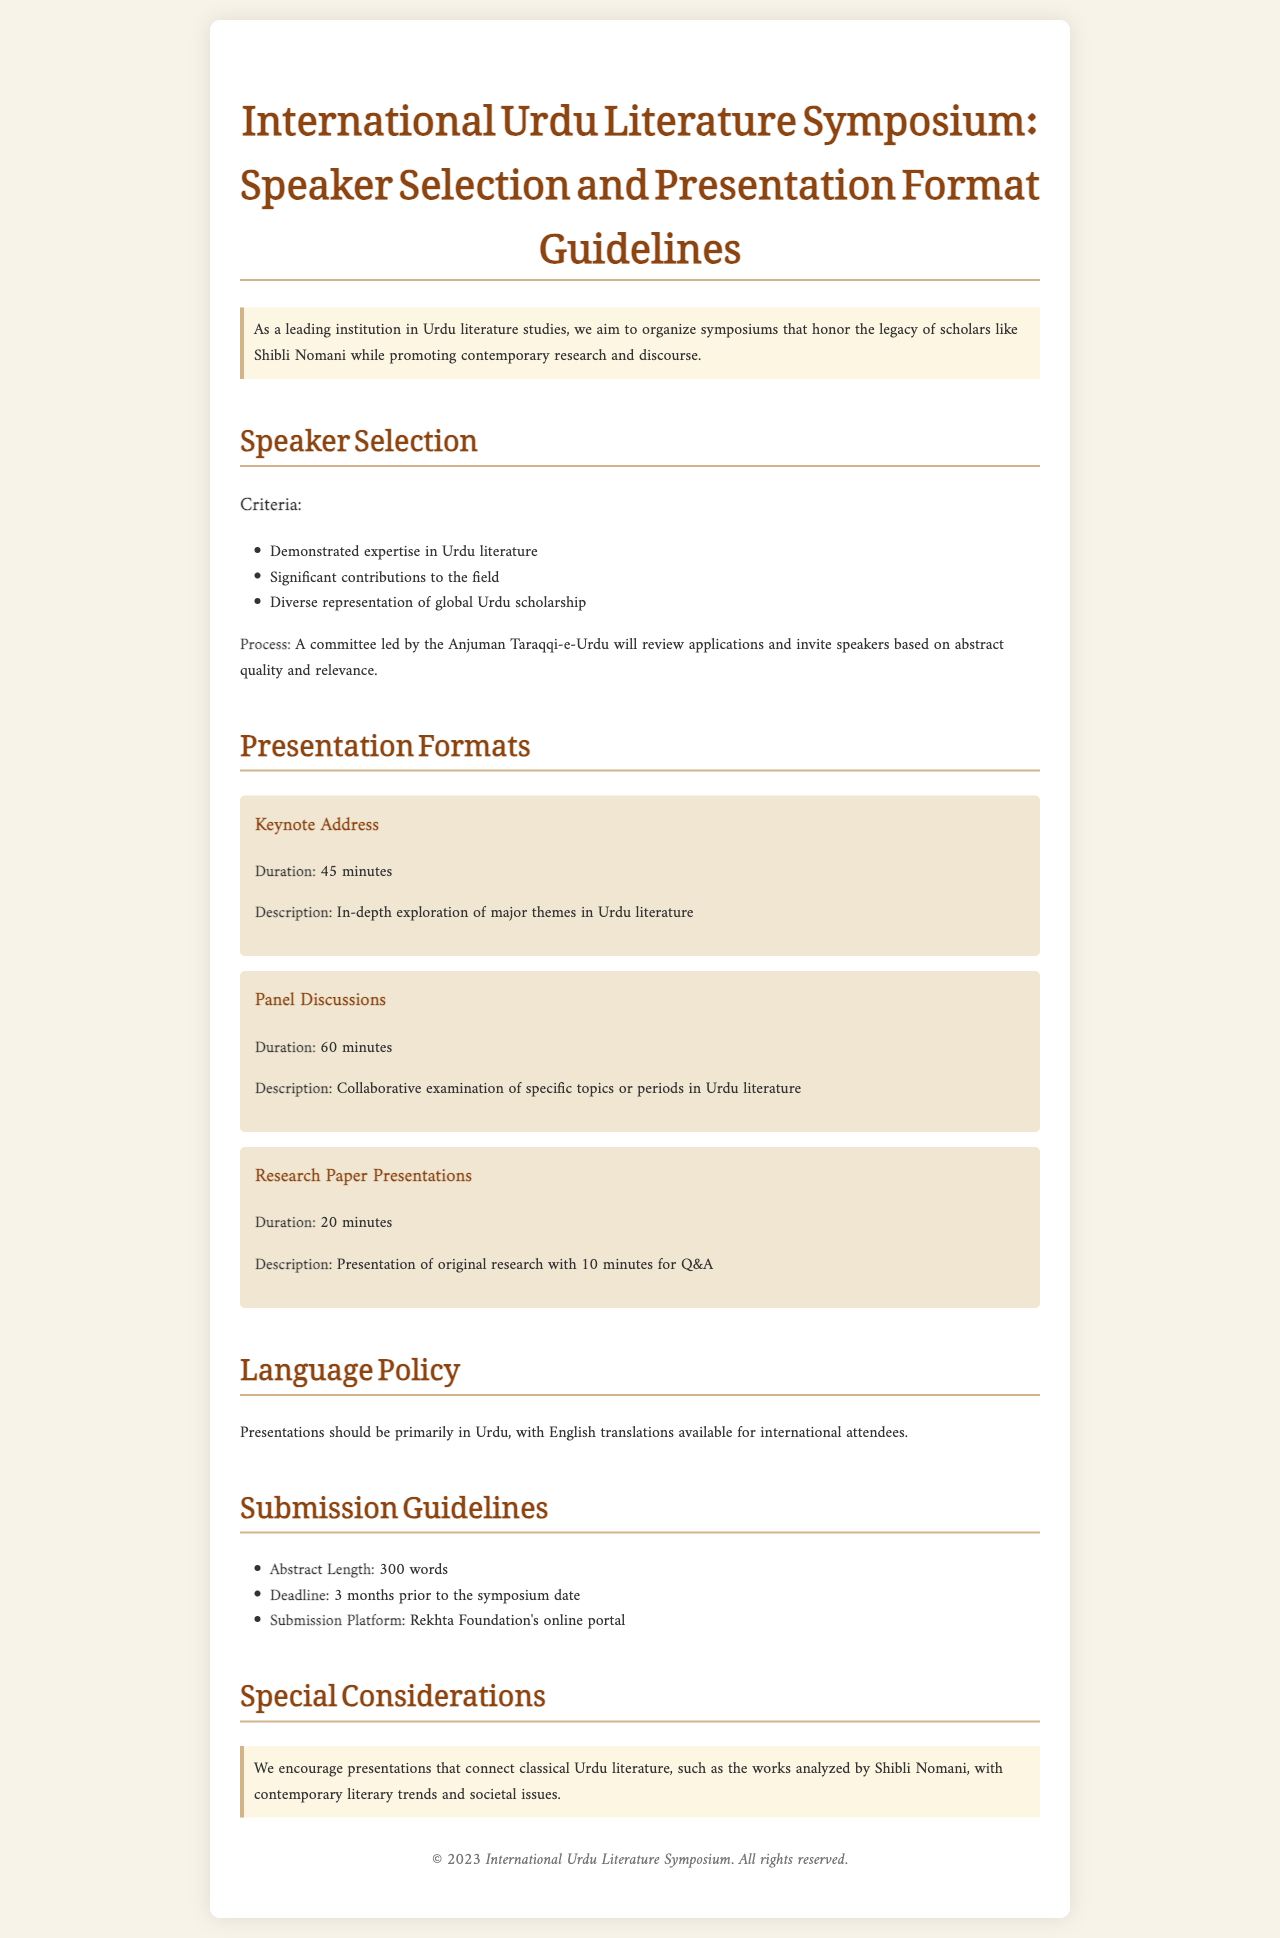What is the duration of the keynote address? The keynote address duration is specified in the document.
Answer: 45 minutes What is the primary language for presentations? The document mentions the language policy for presentations.
Answer: Urdu Who conducts the speaker selection process? The document outlines the committee responsible for speaker selection.
Answer: Anjuman Taraqqi-e-Urdu What is the maximum abstract length for submissions? The maximum length for abstracts is outlined in the submission guidelines.
Answer: 300 words How long is the deadline for submission prior to the symposium? The document provides information on submission deadlines.
Answer: 3 months What type of presentations encourages connections with classical Urdu literature? The document highlights a particular focus within the special considerations section.
Answer: Presentations What is included in panel discussions? The document describes the format and content of panel discussions.
Answer: Specific topics or periods in Urdu literature What is the duration for research paper presentations? The duration of research paper presentations is specifically mentioned in the presentation formats.
Answer: 20 minutes What platform should be used for submissions? The document specifies the platform for submitting abstracts.
Answer: Rekhta Foundation's online portal 